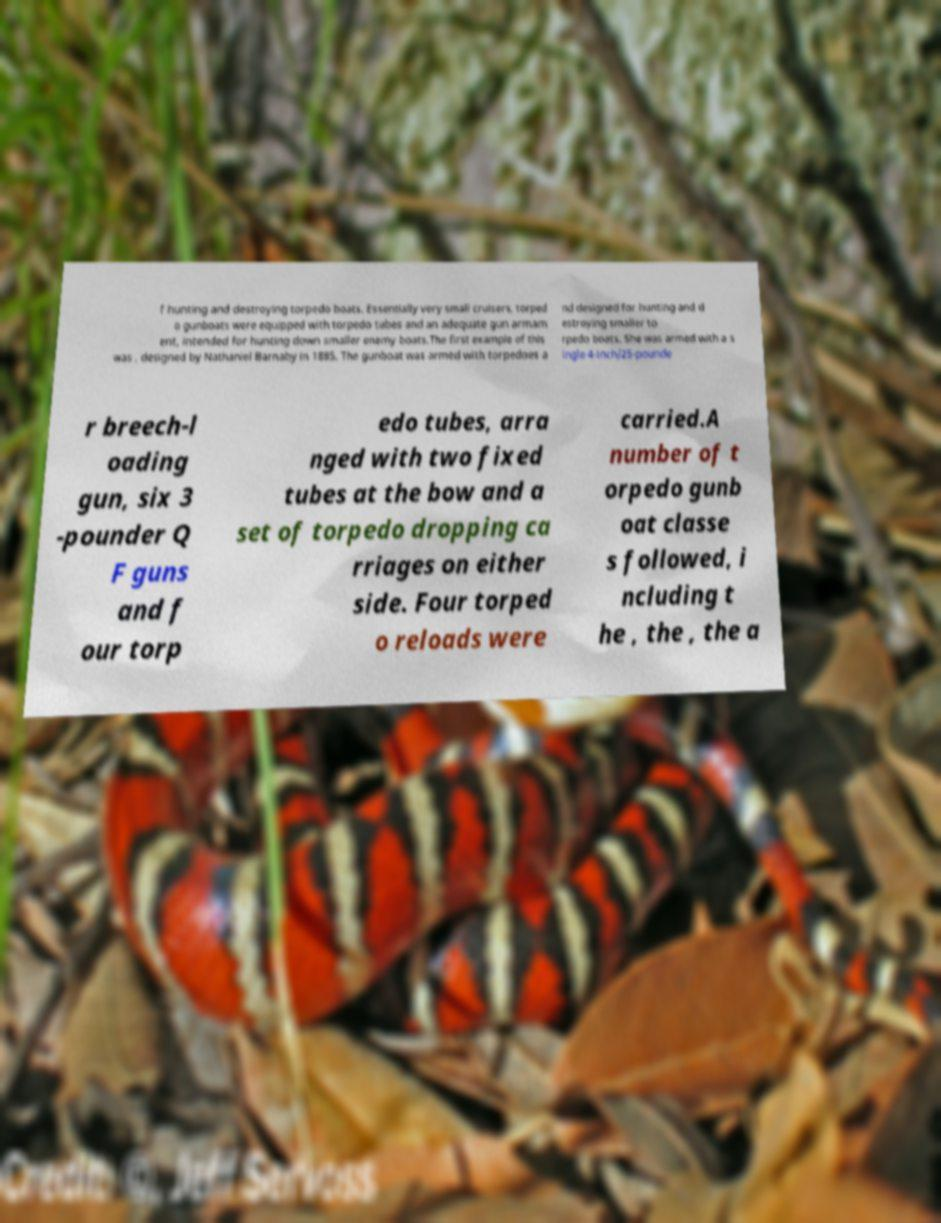Could you extract and type out the text from this image? f hunting and destroying torpedo boats. Essentially very small cruisers, torped o gunboats were equipped with torpedo tubes and an adequate gun armam ent, intended for hunting down smaller enemy boats.The first example of this was , designed by Nathaniel Barnaby in 1885. The gunboat was armed with torpedoes a nd designed for hunting and d estroying smaller to rpedo boats. She was armed with a s ingle 4-inch/25-pounde r breech-l oading gun, six 3 -pounder Q F guns and f our torp edo tubes, arra nged with two fixed tubes at the bow and a set of torpedo dropping ca rriages on either side. Four torped o reloads were carried.A number of t orpedo gunb oat classe s followed, i ncluding t he , the , the a 